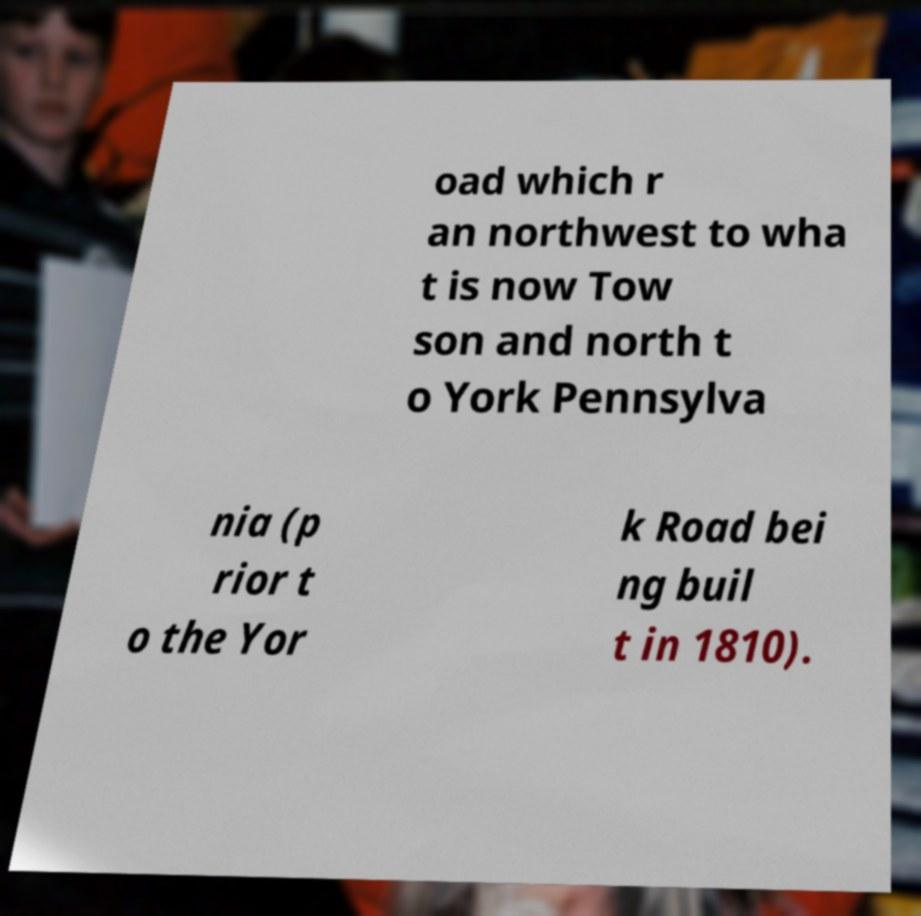What messages or text are displayed in this image? I need them in a readable, typed format. oad which r an northwest to wha t is now Tow son and north t o York Pennsylva nia (p rior t o the Yor k Road bei ng buil t in 1810). 